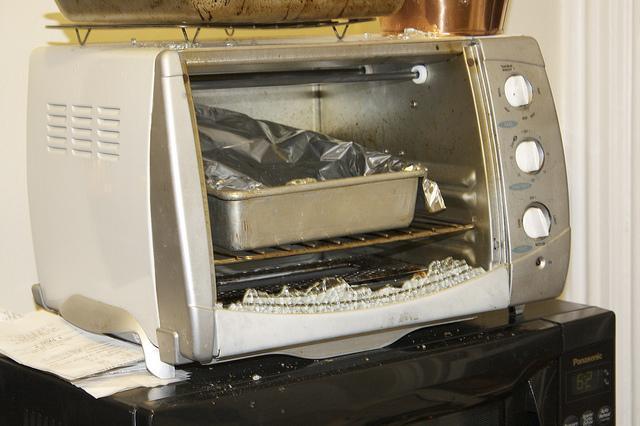How many white knobs are there?
Give a very brief answer. 3. 